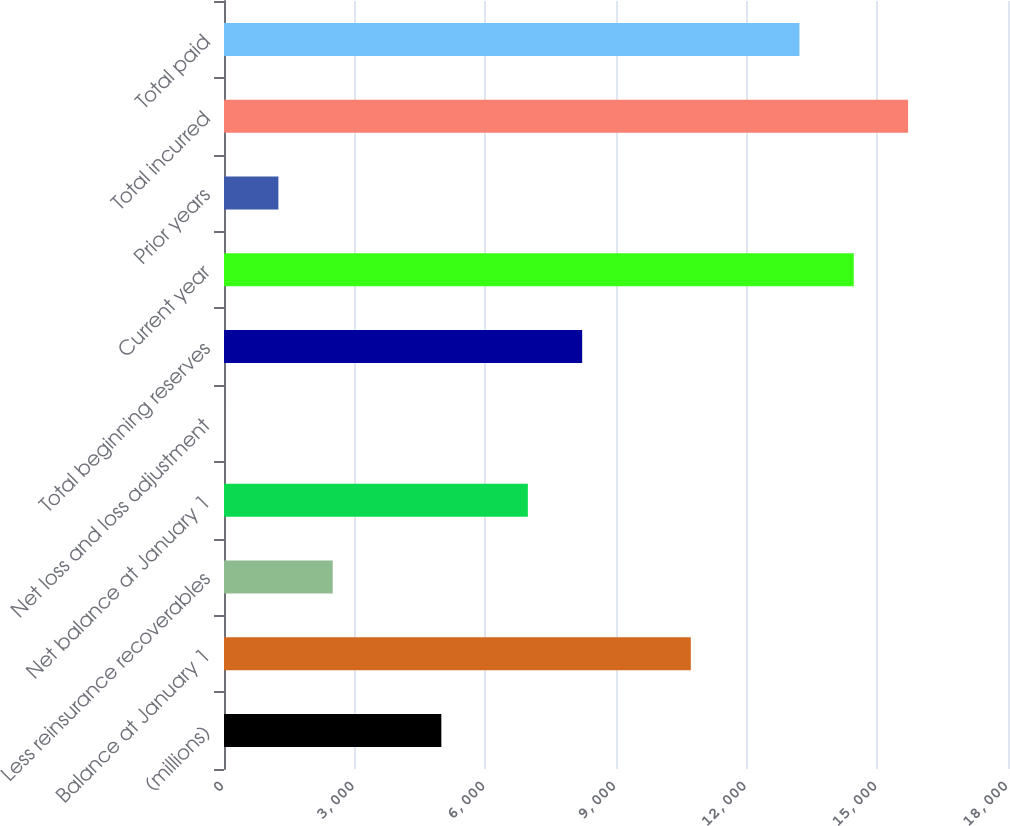<chart> <loc_0><loc_0><loc_500><loc_500><bar_chart><fcel>(millions)<fcel>Balance at January 1<fcel>Less reinsurance recoverables<fcel>Net balance at January 1<fcel>Net loss and loss adjustment<fcel>Total beginning reserves<fcel>Current year<fcel>Prior years<fcel>Total incurred<fcel>Total paid<nl><fcel>4989.94<fcel>10717.5<fcel>2495.78<fcel>6976.3<fcel>1.62<fcel>8223.38<fcel>14458.8<fcel>1248.7<fcel>15705.9<fcel>13211.7<nl></chart> 